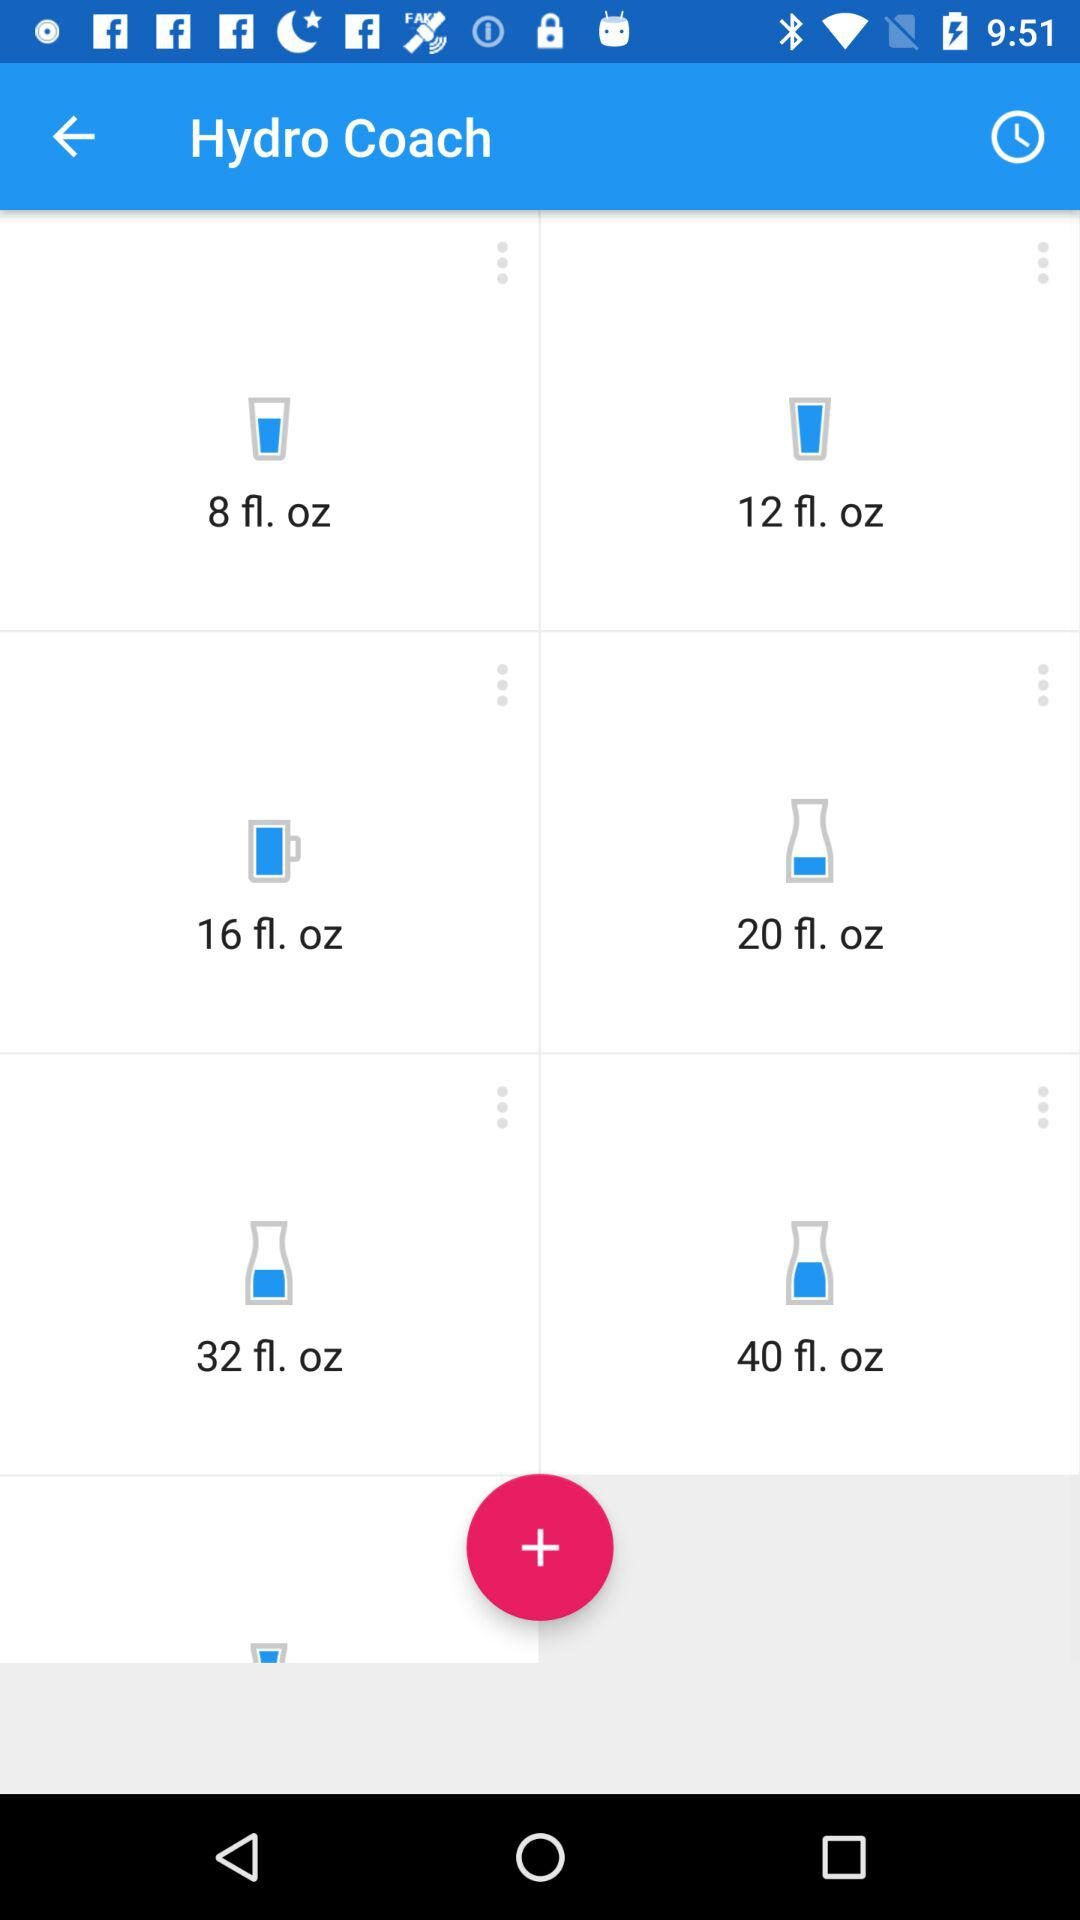How many fluid ounces are in the largest cup size?
Answer the question using a single word or phrase. 40 fl. oz 